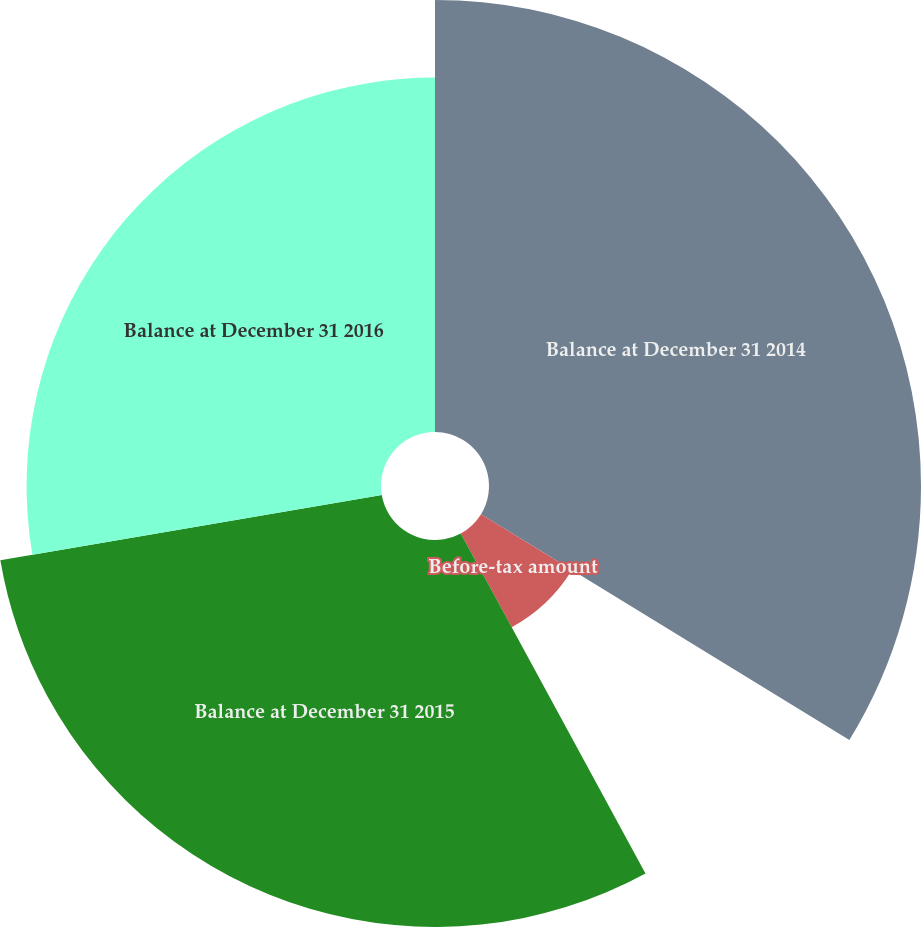Convert chart to OTSL. <chart><loc_0><loc_0><loc_500><loc_500><pie_chart><fcel>Balance at December 31 2014<fcel>Before-tax amount<fcel>Balance at December 31 2015<fcel>Balance at December 31 2016<nl><fcel>33.75%<fcel>8.33%<fcel>30.23%<fcel>27.69%<nl></chart> 